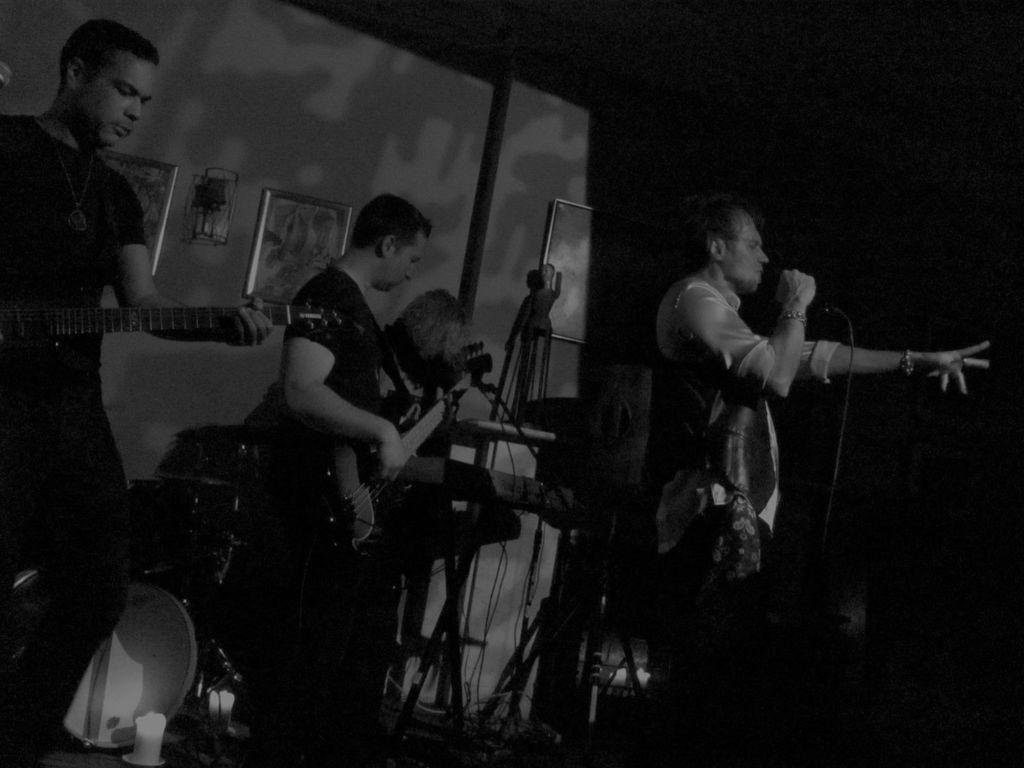What is the color scheme of the image? The image is black and white. What are the persons in the image doing? They are playing guitars in the image. What other musical instrument can be seen in the image? There are drums in the image. What is the man holding in his hand? The man is holding a microphone in his hand. What is the man doing with the microphone? The man is singing. What type of sign is the man holding while singing in the image? There is no sign present in the image; the man is holding a microphone while singing. Can you see a crown on the head of any person in the image? There is no crown visible on anyone's head in the image. 